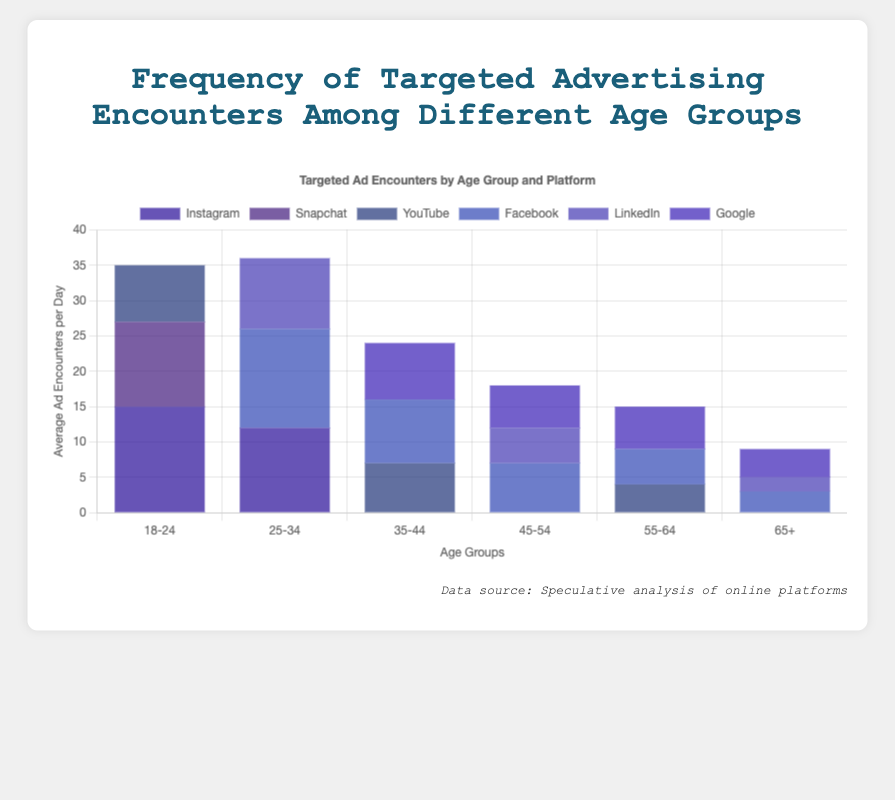What age group encounters the most ads on Instagram? Identify the bar representing Instagram for each age group, then find the highest bar. The 18-24 age group has the highest bar for Instagram at 15 ad encounters per day.
Answer: 18-24 Which platform has the highest average ad encounters for the 35-44 age group? Locate the bars for each platform within the 35-44 age group. The bar for Facebook is the highest at 9.
Answer: Facebook What is the combined number of ad encounters on Facebook and Google for the 45-54 age group? Check the heights of the bars for Facebook and Google within the 45-54 age group, which are 7 and 6, respectively. Sum these values: 7 + 6 = 13.
Answer: 13 How many more targeted ads do 18-24 year-olds encounter on Instagram compared to YouTube? Subtract the number of ad encounters on YouTube for the 18-24 age group (8) from that on Instagram for the same age group (15): 15 - 8 = 7.
Answer: 7 Which age group encounters the least amount of ads on LinkedIn? Compare the bars for LinkedIn across all age groups. The bar for the 65+ age group is the lowest at 2 ad encounters per day.
Answer: 65+ What is the difference between the number of ad encounters on Instagram for the 18-24 age group and the total ad encounters for the 25-34 age group? Determine the number of ad encounters on Instagram for the 18-24 age group (15) and sum the ad encounters for the 25-34 age group (14 + 10 + 12 = 36). Then, subtract: 36 - 15 = 21.
Answer: 21 Does the Google platform have more ad encounters than Facebook for users aged 55-64? Compare the heights of the bars for Google (6) and Facebook (5) for the 55-64 age group. Google has more ad encounters.
Answer: Yes Which platform do the 65+ age group encounter the least ads on, and what is the value? Compare the bars for each platform within the 65+ age group. The LinkedIn bar is the shortest, representing 2 ad encounters per day.
Answer: LinkedIn, 2 What is the average number of ad encounters across all platforms for the 35-44 age group? Sum the ad encounters across all platforms for the 35-44 age group (9 + 8 + 7 = 24). Divide by the number of platforms (3): 24 / 3 = 8.
Answer: 8 